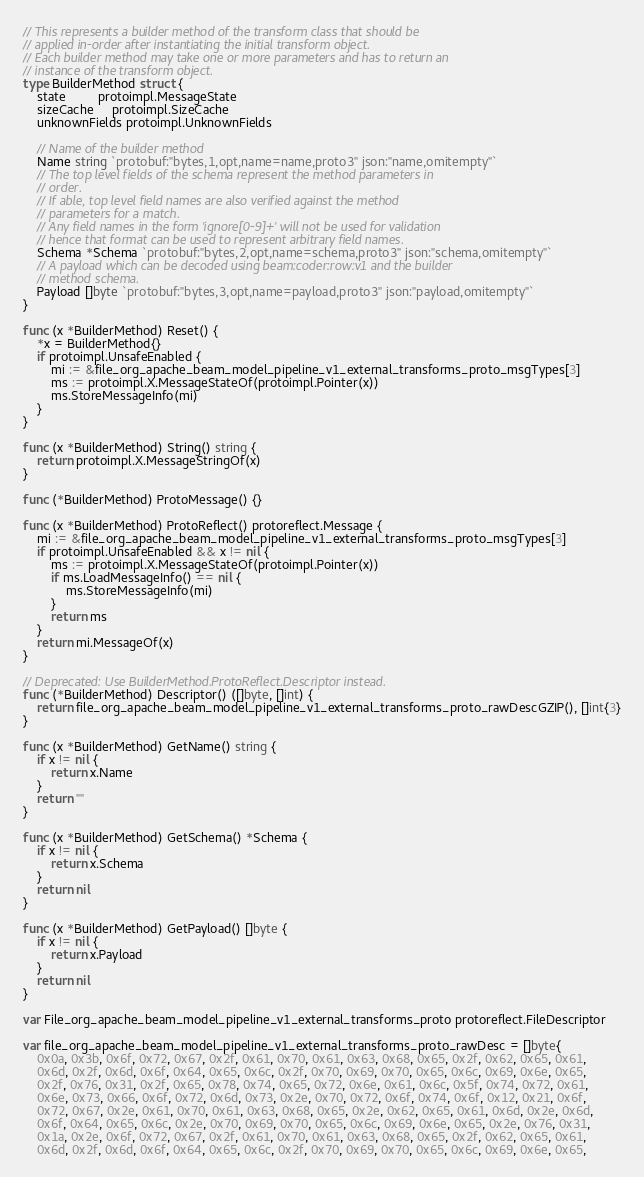Convert code to text. <code><loc_0><loc_0><loc_500><loc_500><_Go_>// This represents a builder method of the transform class that should be
// applied in-order after instantiating the initial transform object.
// Each builder method may take one or more parameters and has to return an
// instance of the transform object.
type BuilderMethod struct {
	state         protoimpl.MessageState
	sizeCache     protoimpl.SizeCache
	unknownFields protoimpl.UnknownFields

	// Name of the builder method
	Name string `protobuf:"bytes,1,opt,name=name,proto3" json:"name,omitempty"`
	// The top level fields of the schema represent the method parameters in
	// order.
	// If able, top level field names are also verified against the method
	// parameters for a match.
	// Any field names in the form 'ignore[0-9]+' will not be used for validation
	// hence that format can be used to represent arbitrary field names.
	Schema *Schema `protobuf:"bytes,2,opt,name=schema,proto3" json:"schema,omitempty"`
	// A payload which can be decoded using beam:coder:row:v1 and the builder
	// method schema.
	Payload []byte `protobuf:"bytes,3,opt,name=payload,proto3" json:"payload,omitempty"`
}

func (x *BuilderMethod) Reset() {
	*x = BuilderMethod{}
	if protoimpl.UnsafeEnabled {
		mi := &file_org_apache_beam_model_pipeline_v1_external_transforms_proto_msgTypes[3]
		ms := protoimpl.X.MessageStateOf(protoimpl.Pointer(x))
		ms.StoreMessageInfo(mi)
	}
}

func (x *BuilderMethod) String() string {
	return protoimpl.X.MessageStringOf(x)
}

func (*BuilderMethod) ProtoMessage() {}

func (x *BuilderMethod) ProtoReflect() protoreflect.Message {
	mi := &file_org_apache_beam_model_pipeline_v1_external_transforms_proto_msgTypes[3]
	if protoimpl.UnsafeEnabled && x != nil {
		ms := protoimpl.X.MessageStateOf(protoimpl.Pointer(x))
		if ms.LoadMessageInfo() == nil {
			ms.StoreMessageInfo(mi)
		}
		return ms
	}
	return mi.MessageOf(x)
}

// Deprecated: Use BuilderMethod.ProtoReflect.Descriptor instead.
func (*BuilderMethod) Descriptor() ([]byte, []int) {
	return file_org_apache_beam_model_pipeline_v1_external_transforms_proto_rawDescGZIP(), []int{3}
}

func (x *BuilderMethod) GetName() string {
	if x != nil {
		return x.Name
	}
	return ""
}

func (x *BuilderMethod) GetSchema() *Schema {
	if x != nil {
		return x.Schema
	}
	return nil
}

func (x *BuilderMethod) GetPayload() []byte {
	if x != nil {
		return x.Payload
	}
	return nil
}

var File_org_apache_beam_model_pipeline_v1_external_transforms_proto protoreflect.FileDescriptor

var file_org_apache_beam_model_pipeline_v1_external_transforms_proto_rawDesc = []byte{
	0x0a, 0x3b, 0x6f, 0x72, 0x67, 0x2f, 0x61, 0x70, 0x61, 0x63, 0x68, 0x65, 0x2f, 0x62, 0x65, 0x61,
	0x6d, 0x2f, 0x6d, 0x6f, 0x64, 0x65, 0x6c, 0x2f, 0x70, 0x69, 0x70, 0x65, 0x6c, 0x69, 0x6e, 0x65,
	0x2f, 0x76, 0x31, 0x2f, 0x65, 0x78, 0x74, 0x65, 0x72, 0x6e, 0x61, 0x6c, 0x5f, 0x74, 0x72, 0x61,
	0x6e, 0x73, 0x66, 0x6f, 0x72, 0x6d, 0x73, 0x2e, 0x70, 0x72, 0x6f, 0x74, 0x6f, 0x12, 0x21, 0x6f,
	0x72, 0x67, 0x2e, 0x61, 0x70, 0x61, 0x63, 0x68, 0x65, 0x2e, 0x62, 0x65, 0x61, 0x6d, 0x2e, 0x6d,
	0x6f, 0x64, 0x65, 0x6c, 0x2e, 0x70, 0x69, 0x70, 0x65, 0x6c, 0x69, 0x6e, 0x65, 0x2e, 0x76, 0x31,
	0x1a, 0x2e, 0x6f, 0x72, 0x67, 0x2f, 0x61, 0x70, 0x61, 0x63, 0x68, 0x65, 0x2f, 0x62, 0x65, 0x61,
	0x6d, 0x2f, 0x6d, 0x6f, 0x64, 0x65, 0x6c, 0x2f, 0x70, 0x69, 0x70, 0x65, 0x6c, 0x69, 0x6e, 0x65,</code> 